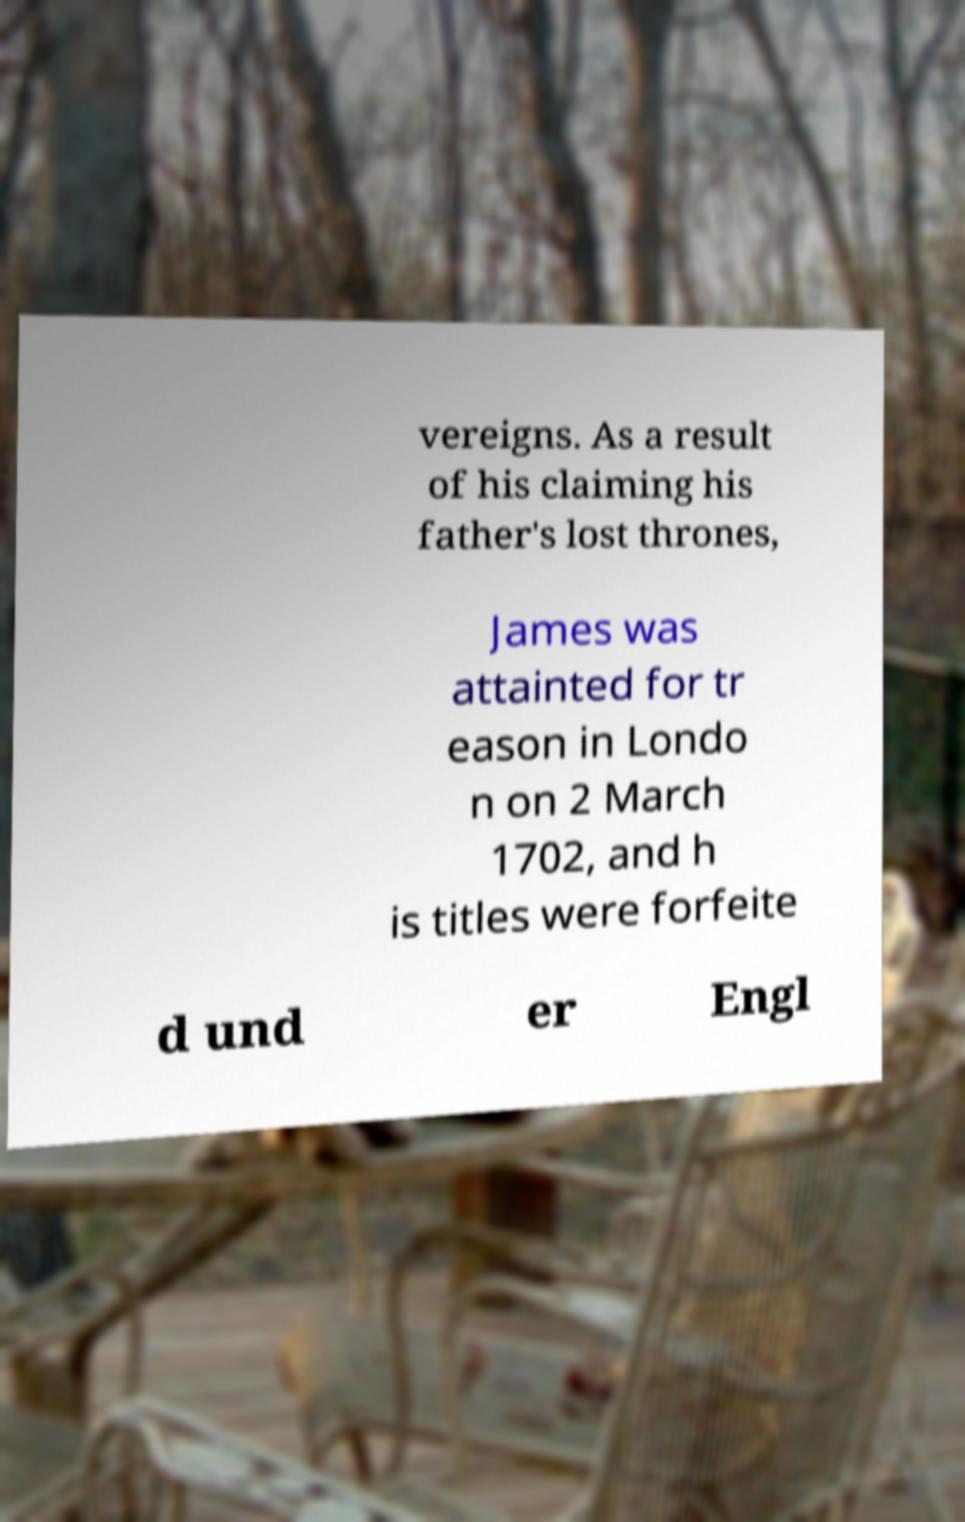What messages or text are displayed in this image? I need them in a readable, typed format. vereigns. As a result of his claiming his father's lost thrones, James was attainted for tr eason in Londo n on 2 March 1702, and h is titles were forfeite d und er Engl 